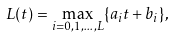<formula> <loc_0><loc_0><loc_500><loc_500>L ( t ) = \max _ { i = 0 , 1 , \dots , L } \{ a _ { i } t + b _ { i } \} ,</formula> 